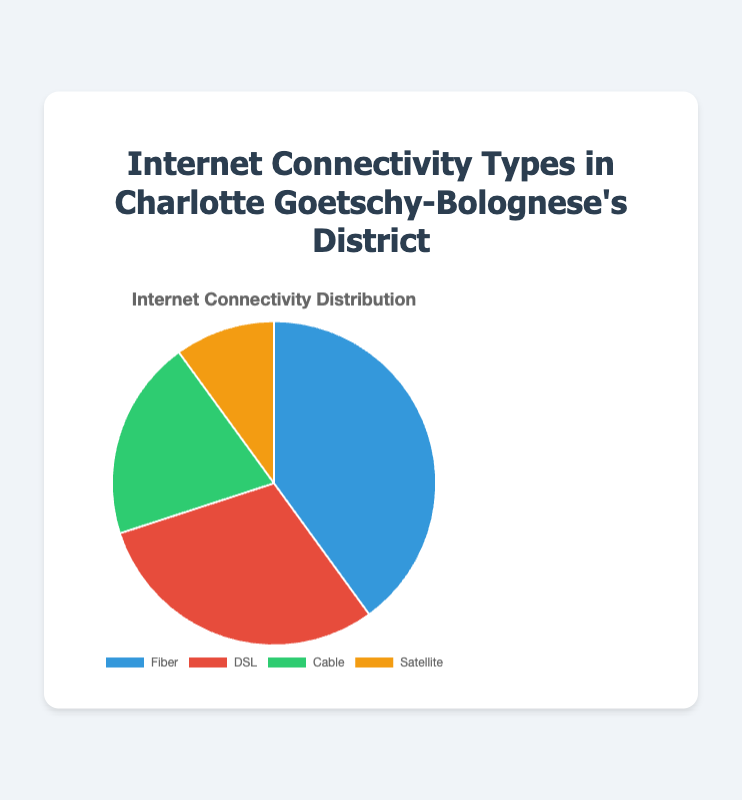What percentage of internet connectivity types is not Fiber? To find the percentage of internet connectivity types that is not Fiber, we need to subtract the percentage of Fiber (40%) from the total percentage (100%). Calculation: 100% - 40% = 60%.
Answer: 60% Which internet connectivity type is the least common in the district? To determine the least common type, we compare the percentages. Fiber: 40%, DSL: 30%, Cable: 20%, Satellite: 10%. The smallest percentage is 10%, which corresponds to Satellite.
Answer: Satellite How much greater is the percentage of Fiber compared to Satellite? To find the difference between the percentage of Fiber and Satellite, we subtract the percentage of Satellite (10%) from Fiber (40%). Calculation: 40% - 10% = 30%.
Answer: 30% What is the combined percentage of DSL and Cable connectivity types? To find the combined percentage, we add the percentage of DSL (30%) and Cable (20%). Calculation: 30% + 20% = 50%.
Answer: 50% Which internet connectivity type has a green color in the pie chart? The pie chart colors are Fiber (blue), DSL (red), Cable (green), and Satellite (yellow). So, the green color corresponds to Cable.
Answer: Cable Is the percentage of Fiber internet greater than the combined percentage of Cable and Satellite? First, we find the combined percentage of Cable and Satellite: 20% (Cable) + 10% (Satellite) = 30%. Then we compare it to Fiber's percentage (40%). Since 40% > 30%, Fiber is greater.
Answer: Yes How much greater is the percentage of DSL than Cable? To find the difference between the percentage of DSL and Cable, we subtract the percentage of Cable (20%) from DSL (30%). Calculation: 30% - 20% = 10%.
Answer: 10% What is the average percentage of all internet connectivity types in the district? To find the average, we sum up the percentages of all types and divide by the number of types. Calculation: (40% + 30% + 20% + 10%) / 4 = 100% / 4 = 25%.
Answer: 25% Which internet connectivity types together make up more than half of the total percentage? We need to choose types that together exceed 50%. Fiber (40%) + DSL (30%) = 70%, which is more than half. So, Fiber and DSL together exceed 50%.
Answer: Fiber and DSL 